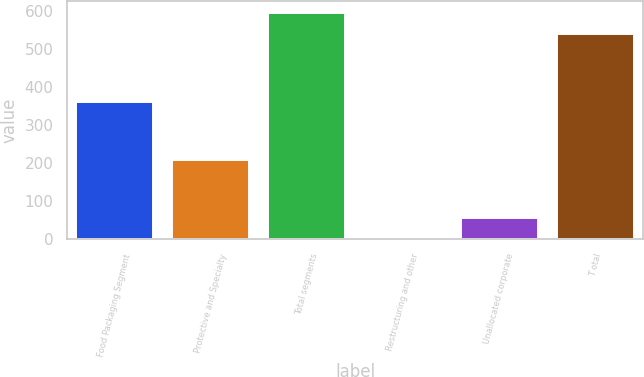Convert chart. <chart><loc_0><loc_0><loc_500><loc_500><bar_chart><fcel>Food Packaging Segment<fcel>Protective and Specialty<fcel>Total segments<fcel>Restructuring and other<fcel>Unallocated corporate<fcel>T otal<nl><fcel>361.6<fcel>209.5<fcel>596.26<fcel>0.5<fcel>57.56<fcel>539.2<nl></chart> 